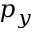Convert formula to latex. <formula><loc_0><loc_0><loc_500><loc_500>p _ { y }</formula> 